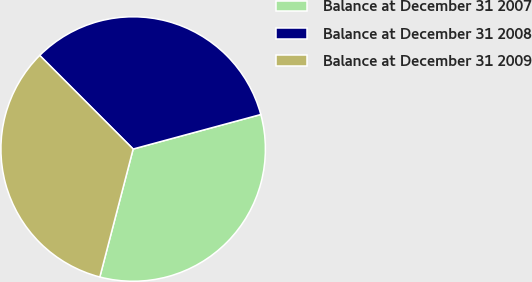<chart> <loc_0><loc_0><loc_500><loc_500><pie_chart><fcel>Balance at December 31 2007<fcel>Balance at December 31 2008<fcel>Balance at December 31 2009<nl><fcel>33.26%<fcel>33.28%<fcel>33.46%<nl></chart> 